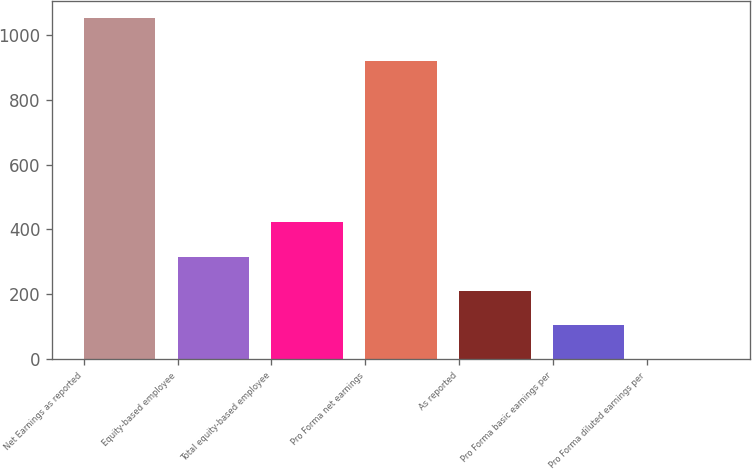<chart> <loc_0><loc_0><loc_500><loc_500><bar_chart><fcel>Net Earnings as reported<fcel>Equity-based employee<fcel>Total equity-based employee<fcel>Pro Forma net earnings<fcel>As reported<fcel>Pro Forma basic earnings per<fcel>Pro Forma diluted earnings per<nl><fcel>1050.7<fcel>316.7<fcel>421.56<fcel>918.1<fcel>211.84<fcel>106.98<fcel>2.12<nl></chart> 